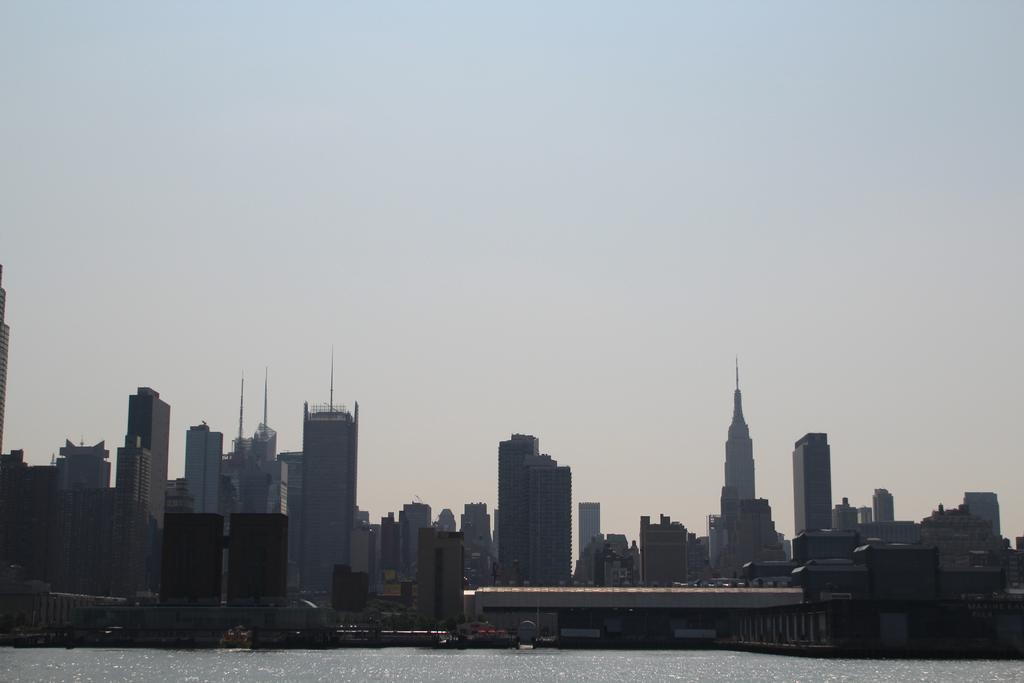Describe this image in one or two sentences. In this picture we can observe some buildings. There is a river. In the background we can observe sky. 